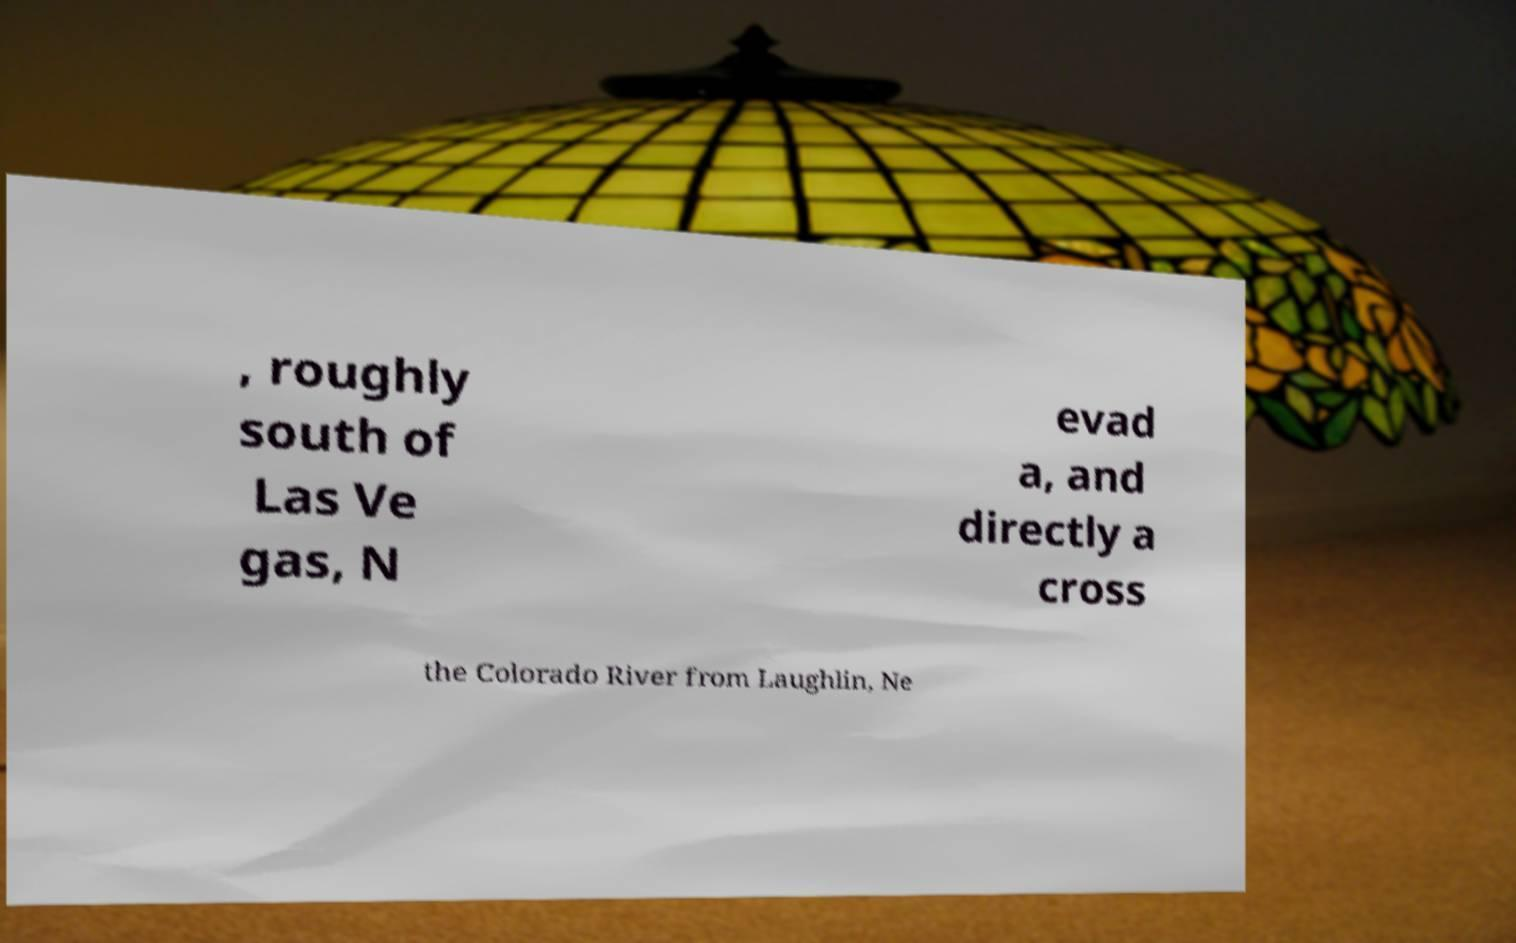There's text embedded in this image that I need extracted. Can you transcribe it verbatim? , roughly south of Las Ve gas, N evad a, and directly a cross the Colorado River from Laughlin, Ne 